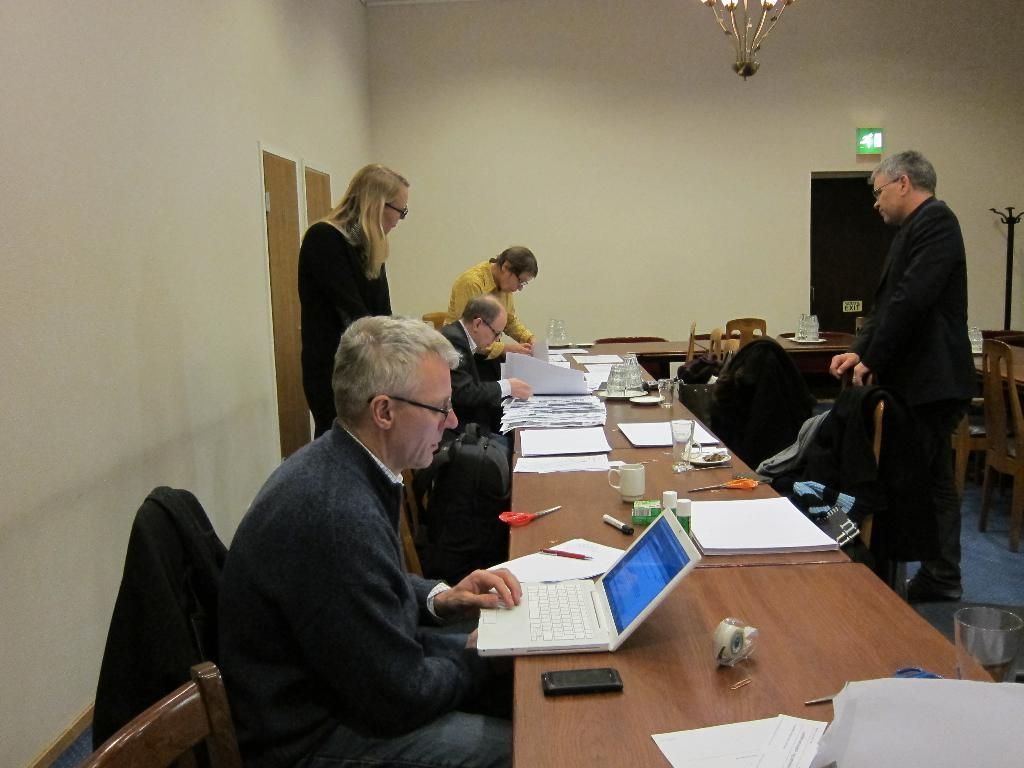How many people are in the image? There is a group of people in the image. What are the people doing in the image? Some people are sitting on chairs, and some are standing on the floor. What is on the table in the image? There is a laptop and other objects on the table. Can you describe the position of the laptop on the table? The laptop is present on the table. How many cherries are on the laptop in the image? There are no cherries present on the laptop or in the image. What is the position of the sun in the image? There is no sun visible in the image. 